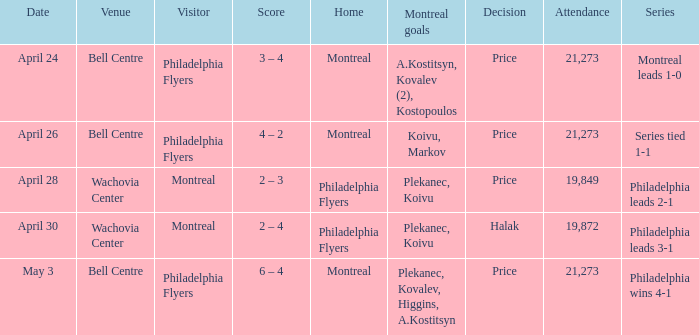When the decision was based on price and montreal was the visiting team, what was the average attendance? 19849.0. 